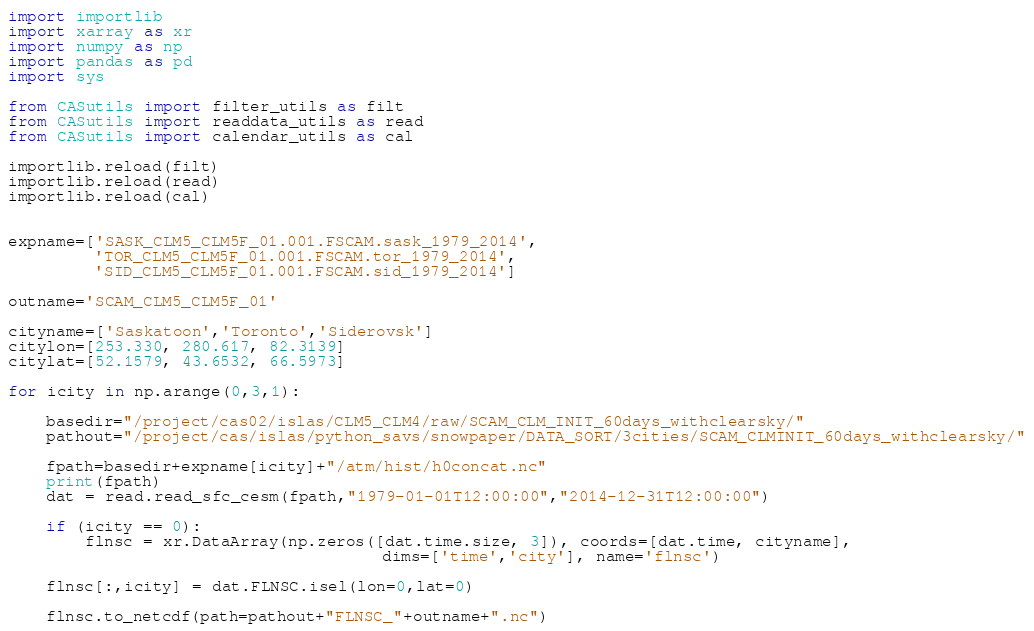<code> <loc_0><loc_0><loc_500><loc_500><_Python_>import importlib
import xarray as xr
import numpy as np
import pandas as pd
import sys

from CASutils import filter_utils as filt
from CASutils import readdata_utils as read
from CASutils import calendar_utils as cal

importlib.reload(filt)
importlib.reload(read)
importlib.reload(cal)


expname=['SASK_CLM5_CLM5F_01.001.FSCAM.sask_1979_2014',
         'TOR_CLM5_CLM5F_01.001.FSCAM.tor_1979_2014',
         'SID_CLM5_CLM5F_01.001.FSCAM.sid_1979_2014']

outname='SCAM_CLM5_CLM5F_01'

cityname=['Saskatoon','Toronto','Siderovsk']
citylon=[253.330, 280.617, 82.3139]
citylat=[52.1579, 43.6532, 66.5973]

for icity in np.arange(0,3,1):

    basedir="/project/cas02/islas/CLM5_CLM4/raw/SCAM_CLM_INIT_60days_withclearsky/"
    pathout="/project/cas/islas/python_savs/snowpaper/DATA_SORT/3cities/SCAM_CLMINIT_60days_withclearsky/"
    
    fpath=basedir+expname[icity]+"/atm/hist/h0concat.nc"
    print(fpath)
    dat = read.read_sfc_cesm(fpath,"1979-01-01T12:00:00","2014-12-31T12:00:00")
   
    if (icity == 0): 
        flnsc = xr.DataArray(np.zeros([dat.time.size, 3]), coords=[dat.time, cityname],
                                       dims=['time','city'], name='flnsc')
    
    flnsc[:,icity] = dat.FLNSC.isel(lon=0,lat=0)
    
    flnsc.to_netcdf(path=pathout+"FLNSC_"+outname+".nc")
</code> 